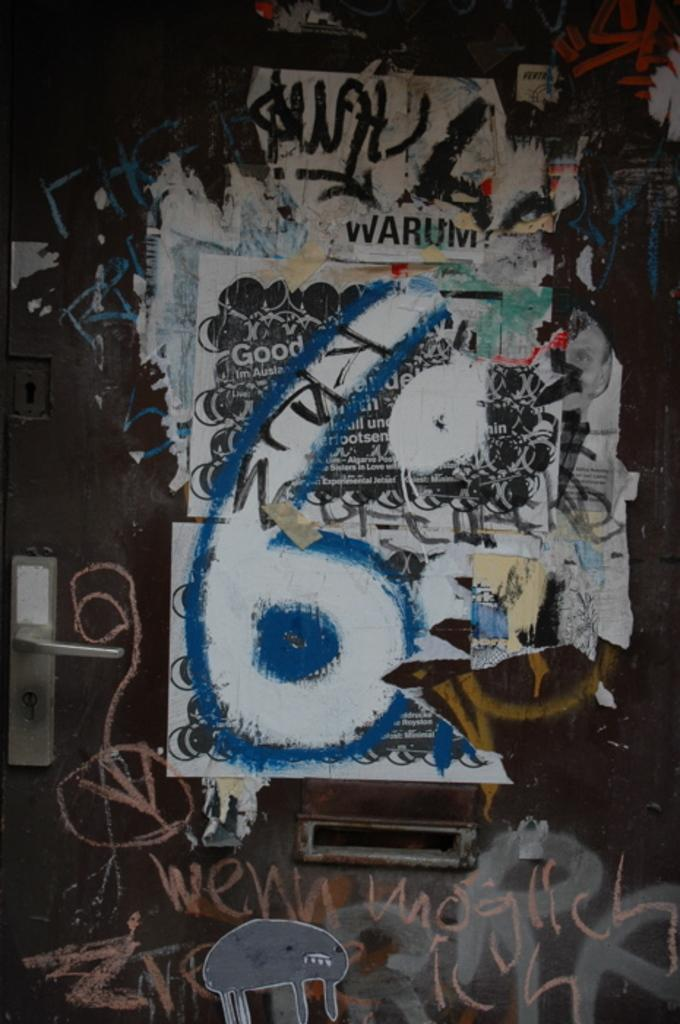What type of object in the image resembles a door? There is a metal object in the image that resembles a door. Where is the knob located on the metal object? The knob is on the left side of the metal object. What is attached to the metal object? White color papers are attached to the metal object. What can be read on the papers? There is text visible on the papers. Can you describe the sea visible in the image? There is no sea visible in the image; it features a metal object with attached papers. What type of trail can be seen leading up to the metal object? There is no trail visible in the image; it only shows the metal object with attached papers. 